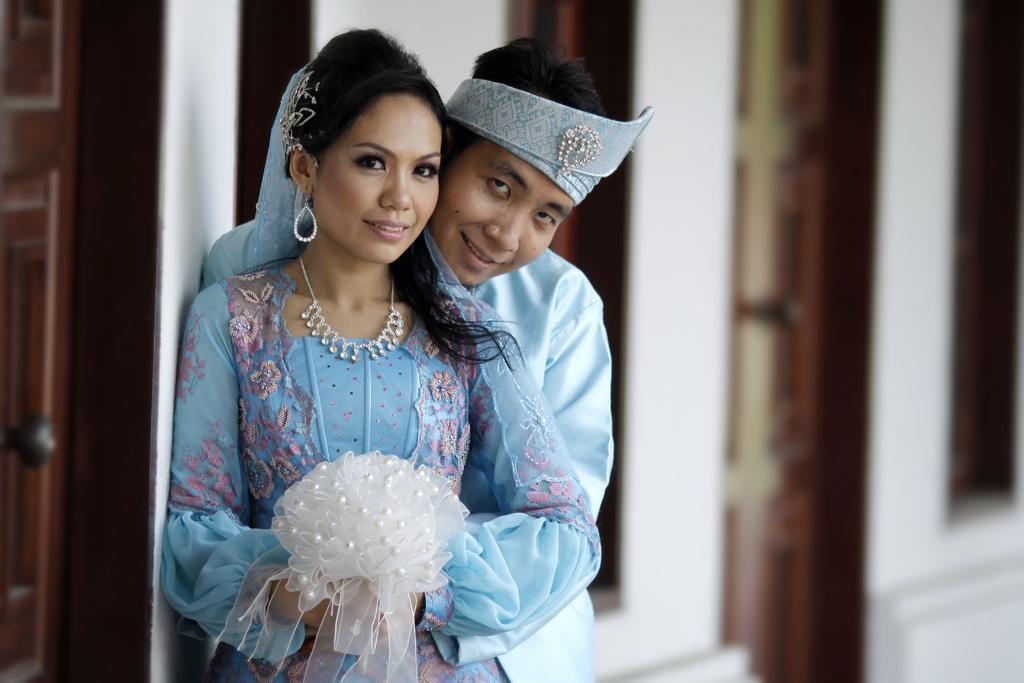In one or two sentences, can you explain what this image depicts? As we can see in the image there is a wall, door and two people wearing blue color dresses. 